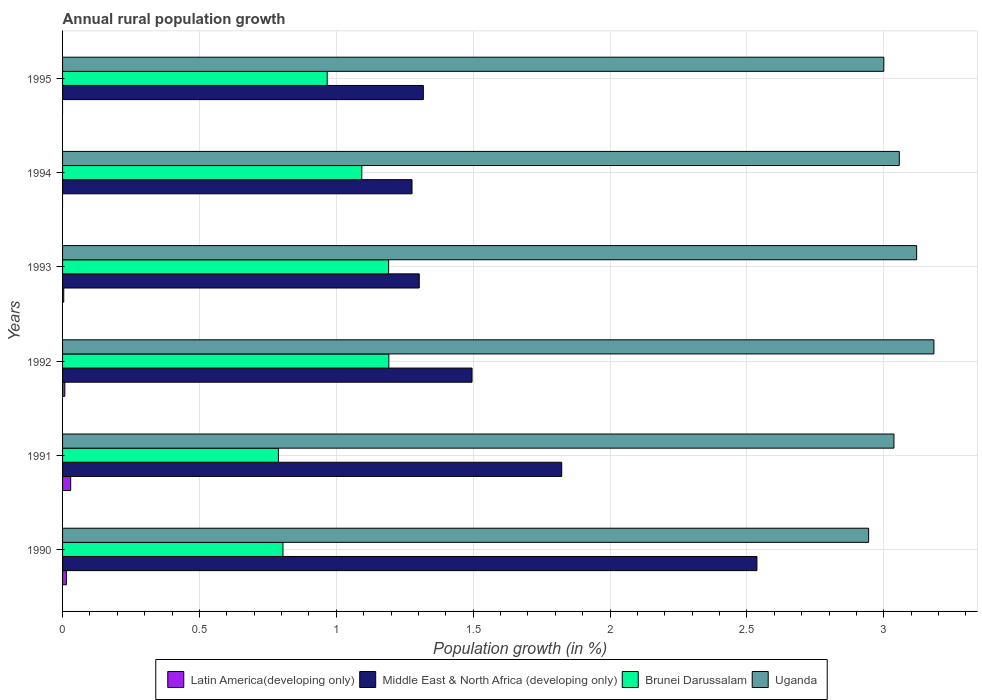How many different coloured bars are there?
Your answer should be compact. 4. Are the number of bars per tick equal to the number of legend labels?
Ensure brevity in your answer.  No. How many bars are there on the 5th tick from the top?
Offer a terse response. 4. What is the label of the 3rd group of bars from the top?
Provide a short and direct response. 1993. In how many cases, is the number of bars for a given year not equal to the number of legend labels?
Provide a short and direct response. 2. What is the percentage of rural population growth in Middle East & North Africa (developing only) in 1993?
Your answer should be compact. 1.3. Across all years, what is the maximum percentage of rural population growth in Latin America(developing only)?
Provide a succinct answer. 0.03. What is the total percentage of rural population growth in Brunei Darussalam in the graph?
Your answer should be very brief. 6.04. What is the difference between the percentage of rural population growth in Latin America(developing only) in 1991 and that in 1992?
Your response must be concise. 0.02. What is the difference between the percentage of rural population growth in Uganda in 1990 and the percentage of rural population growth in Middle East & North Africa (developing only) in 1991?
Keep it short and to the point. 1.12. What is the average percentage of rural population growth in Brunei Darussalam per year?
Make the answer very short. 1.01. In the year 1990, what is the difference between the percentage of rural population growth in Middle East & North Africa (developing only) and percentage of rural population growth in Uganda?
Provide a succinct answer. -0.41. What is the ratio of the percentage of rural population growth in Middle East & North Africa (developing only) in 1993 to that in 1995?
Ensure brevity in your answer.  0.99. Is the percentage of rural population growth in Middle East & North Africa (developing only) in 1992 less than that in 1993?
Give a very brief answer. No. What is the difference between the highest and the second highest percentage of rural population growth in Uganda?
Your response must be concise. 0.06. What is the difference between the highest and the lowest percentage of rural population growth in Uganda?
Provide a succinct answer. 0.24. Is the sum of the percentage of rural population growth in Middle East & North Africa (developing only) in 1994 and 1995 greater than the maximum percentage of rural population growth in Latin America(developing only) across all years?
Provide a succinct answer. Yes. Is it the case that in every year, the sum of the percentage of rural population growth in Uganda and percentage of rural population growth in Latin America(developing only) is greater than the percentage of rural population growth in Brunei Darussalam?
Your answer should be compact. Yes. How many bars are there?
Make the answer very short. 22. Are all the bars in the graph horizontal?
Your answer should be compact. Yes. Are the values on the major ticks of X-axis written in scientific E-notation?
Make the answer very short. No. Does the graph contain any zero values?
Your answer should be very brief. Yes. What is the title of the graph?
Ensure brevity in your answer.  Annual rural population growth. Does "Middle income" appear as one of the legend labels in the graph?
Offer a very short reply. No. What is the label or title of the X-axis?
Keep it short and to the point. Population growth (in %). What is the Population growth (in %) of Latin America(developing only) in 1990?
Give a very brief answer. 0.01. What is the Population growth (in %) of Middle East & North Africa (developing only) in 1990?
Your response must be concise. 2.54. What is the Population growth (in %) of Brunei Darussalam in 1990?
Offer a very short reply. 0.81. What is the Population growth (in %) of Uganda in 1990?
Your response must be concise. 2.94. What is the Population growth (in %) in Latin America(developing only) in 1991?
Offer a terse response. 0.03. What is the Population growth (in %) in Middle East & North Africa (developing only) in 1991?
Offer a terse response. 1.82. What is the Population growth (in %) of Brunei Darussalam in 1991?
Ensure brevity in your answer.  0.79. What is the Population growth (in %) of Uganda in 1991?
Provide a succinct answer. 3.04. What is the Population growth (in %) in Latin America(developing only) in 1992?
Your response must be concise. 0.01. What is the Population growth (in %) of Middle East & North Africa (developing only) in 1992?
Your answer should be very brief. 1.5. What is the Population growth (in %) of Brunei Darussalam in 1992?
Make the answer very short. 1.19. What is the Population growth (in %) of Uganda in 1992?
Keep it short and to the point. 3.18. What is the Population growth (in %) in Latin America(developing only) in 1993?
Your answer should be compact. 0. What is the Population growth (in %) of Middle East & North Africa (developing only) in 1993?
Offer a very short reply. 1.3. What is the Population growth (in %) of Brunei Darussalam in 1993?
Your answer should be very brief. 1.19. What is the Population growth (in %) of Uganda in 1993?
Provide a short and direct response. 3.12. What is the Population growth (in %) in Latin America(developing only) in 1994?
Offer a terse response. 0. What is the Population growth (in %) of Middle East & North Africa (developing only) in 1994?
Make the answer very short. 1.28. What is the Population growth (in %) in Brunei Darussalam in 1994?
Provide a succinct answer. 1.09. What is the Population growth (in %) in Uganda in 1994?
Your response must be concise. 3.06. What is the Population growth (in %) in Latin America(developing only) in 1995?
Provide a succinct answer. 0. What is the Population growth (in %) of Middle East & North Africa (developing only) in 1995?
Your answer should be very brief. 1.32. What is the Population growth (in %) in Brunei Darussalam in 1995?
Offer a terse response. 0.97. What is the Population growth (in %) in Uganda in 1995?
Provide a succinct answer. 3. Across all years, what is the maximum Population growth (in %) in Latin America(developing only)?
Make the answer very short. 0.03. Across all years, what is the maximum Population growth (in %) of Middle East & North Africa (developing only)?
Make the answer very short. 2.54. Across all years, what is the maximum Population growth (in %) of Brunei Darussalam?
Your answer should be very brief. 1.19. Across all years, what is the maximum Population growth (in %) in Uganda?
Offer a terse response. 3.18. Across all years, what is the minimum Population growth (in %) in Middle East & North Africa (developing only)?
Provide a short and direct response. 1.28. Across all years, what is the minimum Population growth (in %) of Brunei Darussalam?
Provide a short and direct response. 0.79. Across all years, what is the minimum Population growth (in %) of Uganda?
Make the answer very short. 2.94. What is the total Population growth (in %) in Latin America(developing only) in the graph?
Make the answer very short. 0.06. What is the total Population growth (in %) in Middle East & North Africa (developing only) in the graph?
Offer a very short reply. 9.75. What is the total Population growth (in %) of Brunei Darussalam in the graph?
Offer a very short reply. 6.04. What is the total Population growth (in %) of Uganda in the graph?
Offer a very short reply. 18.34. What is the difference between the Population growth (in %) of Latin America(developing only) in 1990 and that in 1991?
Your answer should be compact. -0.02. What is the difference between the Population growth (in %) in Middle East & North Africa (developing only) in 1990 and that in 1991?
Offer a very short reply. 0.71. What is the difference between the Population growth (in %) in Brunei Darussalam in 1990 and that in 1991?
Make the answer very short. 0.02. What is the difference between the Population growth (in %) in Uganda in 1990 and that in 1991?
Your answer should be compact. -0.09. What is the difference between the Population growth (in %) of Latin America(developing only) in 1990 and that in 1992?
Provide a succinct answer. 0.01. What is the difference between the Population growth (in %) in Middle East & North Africa (developing only) in 1990 and that in 1992?
Your response must be concise. 1.04. What is the difference between the Population growth (in %) of Brunei Darussalam in 1990 and that in 1992?
Make the answer very short. -0.39. What is the difference between the Population growth (in %) in Uganda in 1990 and that in 1992?
Offer a terse response. -0.24. What is the difference between the Population growth (in %) in Latin America(developing only) in 1990 and that in 1993?
Provide a short and direct response. 0.01. What is the difference between the Population growth (in %) of Middle East & North Africa (developing only) in 1990 and that in 1993?
Your answer should be very brief. 1.23. What is the difference between the Population growth (in %) of Brunei Darussalam in 1990 and that in 1993?
Your answer should be compact. -0.39. What is the difference between the Population growth (in %) in Uganda in 1990 and that in 1993?
Give a very brief answer. -0.18. What is the difference between the Population growth (in %) in Middle East & North Africa (developing only) in 1990 and that in 1994?
Your answer should be very brief. 1.26. What is the difference between the Population growth (in %) in Brunei Darussalam in 1990 and that in 1994?
Your answer should be very brief. -0.29. What is the difference between the Population growth (in %) of Uganda in 1990 and that in 1994?
Your answer should be compact. -0.11. What is the difference between the Population growth (in %) of Middle East & North Africa (developing only) in 1990 and that in 1995?
Ensure brevity in your answer.  1.22. What is the difference between the Population growth (in %) of Brunei Darussalam in 1990 and that in 1995?
Offer a terse response. -0.16. What is the difference between the Population growth (in %) of Uganda in 1990 and that in 1995?
Make the answer very short. -0.06. What is the difference between the Population growth (in %) of Latin America(developing only) in 1991 and that in 1992?
Your answer should be compact. 0.02. What is the difference between the Population growth (in %) of Middle East & North Africa (developing only) in 1991 and that in 1992?
Ensure brevity in your answer.  0.33. What is the difference between the Population growth (in %) of Brunei Darussalam in 1991 and that in 1992?
Provide a succinct answer. -0.4. What is the difference between the Population growth (in %) of Uganda in 1991 and that in 1992?
Give a very brief answer. -0.15. What is the difference between the Population growth (in %) of Latin America(developing only) in 1991 and that in 1993?
Provide a succinct answer. 0.03. What is the difference between the Population growth (in %) of Middle East & North Africa (developing only) in 1991 and that in 1993?
Offer a very short reply. 0.52. What is the difference between the Population growth (in %) of Brunei Darussalam in 1991 and that in 1993?
Your response must be concise. -0.4. What is the difference between the Population growth (in %) of Uganda in 1991 and that in 1993?
Keep it short and to the point. -0.08. What is the difference between the Population growth (in %) of Middle East & North Africa (developing only) in 1991 and that in 1994?
Offer a terse response. 0.55. What is the difference between the Population growth (in %) in Brunei Darussalam in 1991 and that in 1994?
Your answer should be very brief. -0.3. What is the difference between the Population growth (in %) in Uganda in 1991 and that in 1994?
Your answer should be very brief. -0.02. What is the difference between the Population growth (in %) in Middle East & North Africa (developing only) in 1991 and that in 1995?
Your answer should be compact. 0.51. What is the difference between the Population growth (in %) of Brunei Darussalam in 1991 and that in 1995?
Offer a very short reply. -0.18. What is the difference between the Population growth (in %) in Uganda in 1991 and that in 1995?
Offer a terse response. 0.04. What is the difference between the Population growth (in %) in Latin America(developing only) in 1992 and that in 1993?
Your answer should be very brief. 0. What is the difference between the Population growth (in %) of Middle East & North Africa (developing only) in 1992 and that in 1993?
Ensure brevity in your answer.  0.19. What is the difference between the Population growth (in %) of Brunei Darussalam in 1992 and that in 1993?
Your response must be concise. 0. What is the difference between the Population growth (in %) in Uganda in 1992 and that in 1993?
Provide a short and direct response. 0.06. What is the difference between the Population growth (in %) of Middle East & North Africa (developing only) in 1992 and that in 1994?
Ensure brevity in your answer.  0.22. What is the difference between the Population growth (in %) in Brunei Darussalam in 1992 and that in 1994?
Give a very brief answer. 0.1. What is the difference between the Population growth (in %) of Uganda in 1992 and that in 1994?
Make the answer very short. 0.13. What is the difference between the Population growth (in %) in Middle East & North Africa (developing only) in 1992 and that in 1995?
Ensure brevity in your answer.  0.18. What is the difference between the Population growth (in %) in Brunei Darussalam in 1992 and that in 1995?
Your answer should be compact. 0.23. What is the difference between the Population growth (in %) in Uganda in 1992 and that in 1995?
Provide a short and direct response. 0.18. What is the difference between the Population growth (in %) in Middle East & North Africa (developing only) in 1993 and that in 1994?
Ensure brevity in your answer.  0.03. What is the difference between the Population growth (in %) in Brunei Darussalam in 1993 and that in 1994?
Make the answer very short. 0.1. What is the difference between the Population growth (in %) of Uganda in 1993 and that in 1994?
Ensure brevity in your answer.  0.06. What is the difference between the Population growth (in %) in Middle East & North Africa (developing only) in 1993 and that in 1995?
Ensure brevity in your answer.  -0.01. What is the difference between the Population growth (in %) of Brunei Darussalam in 1993 and that in 1995?
Make the answer very short. 0.22. What is the difference between the Population growth (in %) of Uganda in 1993 and that in 1995?
Your response must be concise. 0.12. What is the difference between the Population growth (in %) in Middle East & North Africa (developing only) in 1994 and that in 1995?
Provide a short and direct response. -0.04. What is the difference between the Population growth (in %) of Brunei Darussalam in 1994 and that in 1995?
Offer a very short reply. 0.13. What is the difference between the Population growth (in %) in Uganda in 1994 and that in 1995?
Your response must be concise. 0.06. What is the difference between the Population growth (in %) of Latin America(developing only) in 1990 and the Population growth (in %) of Middle East & North Africa (developing only) in 1991?
Your answer should be very brief. -1.81. What is the difference between the Population growth (in %) in Latin America(developing only) in 1990 and the Population growth (in %) in Brunei Darussalam in 1991?
Offer a very short reply. -0.77. What is the difference between the Population growth (in %) of Latin America(developing only) in 1990 and the Population growth (in %) of Uganda in 1991?
Ensure brevity in your answer.  -3.02. What is the difference between the Population growth (in %) of Middle East & North Africa (developing only) in 1990 and the Population growth (in %) of Brunei Darussalam in 1991?
Your answer should be very brief. 1.75. What is the difference between the Population growth (in %) in Middle East & North Africa (developing only) in 1990 and the Population growth (in %) in Uganda in 1991?
Your answer should be compact. -0.5. What is the difference between the Population growth (in %) of Brunei Darussalam in 1990 and the Population growth (in %) of Uganda in 1991?
Provide a short and direct response. -2.23. What is the difference between the Population growth (in %) of Latin America(developing only) in 1990 and the Population growth (in %) of Middle East & North Africa (developing only) in 1992?
Give a very brief answer. -1.48. What is the difference between the Population growth (in %) of Latin America(developing only) in 1990 and the Population growth (in %) of Brunei Darussalam in 1992?
Your response must be concise. -1.18. What is the difference between the Population growth (in %) of Latin America(developing only) in 1990 and the Population growth (in %) of Uganda in 1992?
Your answer should be compact. -3.17. What is the difference between the Population growth (in %) in Middle East & North Africa (developing only) in 1990 and the Population growth (in %) in Brunei Darussalam in 1992?
Offer a terse response. 1.34. What is the difference between the Population growth (in %) in Middle East & North Africa (developing only) in 1990 and the Population growth (in %) in Uganda in 1992?
Make the answer very short. -0.65. What is the difference between the Population growth (in %) in Brunei Darussalam in 1990 and the Population growth (in %) in Uganda in 1992?
Offer a terse response. -2.38. What is the difference between the Population growth (in %) of Latin America(developing only) in 1990 and the Population growth (in %) of Middle East & North Africa (developing only) in 1993?
Give a very brief answer. -1.29. What is the difference between the Population growth (in %) of Latin America(developing only) in 1990 and the Population growth (in %) of Brunei Darussalam in 1993?
Provide a short and direct response. -1.18. What is the difference between the Population growth (in %) in Latin America(developing only) in 1990 and the Population growth (in %) in Uganda in 1993?
Keep it short and to the point. -3.11. What is the difference between the Population growth (in %) of Middle East & North Africa (developing only) in 1990 and the Population growth (in %) of Brunei Darussalam in 1993?
Keep it short and to the point. 1.35. What is the difference between the Population growth (in %) of Middle East & North Africa (developing only) in 1990 and the Population growth (in %) of Uganda in 1993?
Give a very brief answer. -0.58. What is the difference between the Population growth (in %) in Brunei Darussalam in 1990 and the Population growth (in %) in Uganda in 1993?
Keep it short and to the point. -2.31. What is the difference between the Population growth (in %) of Latin America(developing only) in 1990 and the Population growth (in %) of Middle East & North Africa (developing only) in 1994?
Provide a succinct answer. -1.26. What is the difference between the Population growth (in %) of Latin America(developing only) in 1990 and the Population growth (in %) of Brunei Darussalam in 1994?
Make the answer very short. -1.08. What is the difference between the Population growth (in %) in Latin America(developing only) in 1990 and the Population growth (in %) in Uganda in 1994?
Your answer should be very brief. -3.04. What is the difference between the Population growth (in %) of Middle East & North Africa (developing only) in 1990 and the Population growth (in %) of Brunei Darussalam in 1994?
Make the answer very short. 1.44. What is the difference between the Population growth (in %) in Middle East & North Africa (developing only) in 1990 and the Population growth (in %) in Uganda in 1994?
Provide a short and direct response. -0.52. What is the difference between the Population growth (in %) of Brunei Darussalam in 1990 and the Population growth (in %) of Uganda in 1994?
Provide a short and direct response. -2.25. What is the difference between the Population growth (in %) in Latin America(developing only) in 1990 and the Population growth (in %) in Middle East & North Africa (developing only) in 1995?
Your answer should be very brief. -1.3. What is the difference between the Population growth (in %) in Latin America(developing only) in 1990 and the Population growth (in %) in Brunei Darussalam in 1995?
Your response must be concise. -0.95. What is the difference between the Population growth (in %) of Latin America(developing only) in 1990 and the Population growth (in %) of Uganda in 1995?
Your answer should be very brief. -2.99. What is the difference between the Population growth (in %) of Middle East & North Africa (developing only) in 1990 and the Population growth (in %) of Brunei Darussalam in 1995?
Offer a terse response. 1.57. What is the difference between the Population growth (in %) of Middle East & North Africa (developing only) in 1990 and the Population growth (in %) of Uganda in 1995?
Your answer should be very brief. -0.46. What is the difference between the Population growth (in %) of Brunei Darussalam in 1990 and the Population growth (in %) of Uganda in 1995?
Offer a terse response. -2.19. What is the difference between the Population growth (in %) in Latin America(developing only) in 1991 and the Population growth (in %) in Middle East & North Africa (developing only) in 1992?
Your response must be concise. -1.47. What is the difference between the Population growth (in %) of Latin America(developing only) in 1991 and the Population growth (in %) of Brunei Darussalam in 1992?
Provide a succinct answer. -1.16. What is the difference between the Population growth (in %) in Latin America(developing only) in 1991 and the Population growth (in %) in Uganda in 1992?
Offer a very short reply. -3.15. What is the difference between the Population growth (in %) in Middle East & North Africa (developing only) in 1991 and the Population growth (in %) in Brunei Darussalam in 1992?
Offer a very short reply. 0.63. What is the difference between the Population growth (in %) of Middle East & North Africa (developing only) in 1991 and the Population growth (in %) of Uganda in 1992?
Your response must be concise. -1.36. What is the difference between the Population growth (in %) of Brunei Darussalam in 1991 and the Population growth (in %) of Uganda in 1992?
Provide a succinct answer. -2.39. What is the difference between the Population growth (in %) in Latin America(developing only) in 1991 and the Population growth (in %) in Middle East & North Africa (developing only) in 1993?
Give a very brief answer. -1.27. What is the difference between the Population growth (in %) of Latin America(developing only) in 1991 and the Population growth (in %) of Brunei Darussalam in 1993?
Your answer should be compact. -1.16. What is the difference between the Population growth (in %) of Latin America(developing only) in 1991 and the Population growth (in %) of Uganda in 1993?
Your response must be concise. -3.09. What is the difference between the Population growth (in %) in Middle East & North Africa (developing only) in 1991 and the Population growth (in %) in Brunei Darussalam in 1993?
Provide a succinct answer. 0.63. What is the difference between the Population growth (in %) in Middle East & North Africa (developing only) in 1991 and the Population growth (in %) in Uganda in 1993?
Keep it short and to the point. -1.3. What is the difference between the Population growth (in %) of Brunei Darussalam in 1991 and the Population growth (in %) of Uganda in 1993?
Your answer should be compact. -2.33. What is the difference between the Population growth (in %) of Latin America(developing only) in 1991 and the Population growth (in %) of Middle East & North Africa (developing only) in 1994?
Your answer should be compact. -1.25. What is the difference between the Population growth (in %) in Latin America(developing only) in 1991 and the Population growth (in %) in Brunei Darussalam in 1994?
Keep it short and to the point. -1.06. What is the difference between the Population growth (in %) of Latin America(developing only) in 1991 and the Population growth (in %) of Uganda in 1994?
Offer a terse response. -3.03. What is the difference between the Population growth (in %) of Middle East & North Africa (developing only) in 1991 and the Population growth (in %) of Brunei Darussalam in 1994?
Provide a succinct answer. 0.73. What is the difference between the Population growth (in %) of Middle East & North Africa (developing only) in 1991 and the Population growth (in %) of Uganda in 1994?
Your answer should be compact. -1.23. What is the difference between the Population growth (in %) in Brunei Darussalam in 1991 and the Population growth (in %) in Uganda in 1994?
Ensure brevity in your answer.  -2.27. What is the difference between the Population growth (in %) in Latin America(developing only) in 1991 and the Population growth (in %) in Middle East & North Africa (developing only) in 1995?
Keep it short and to the point. -1.29. What is the difference between the Population growth (in %) of Latin America(developing only) in 1991 and the Population growth (in %) of Brunei Darussalam in 1995?
Provide a short and direct response. -0.94. What is the difference between the Population growth (in %) in Latin America(developing only) in 1991 and the Population growth (in %) in Uganda in 1995?
Offer a very short reply. -2.97. What is the difference between the Population growth (in %) of Middle East & North Africa (developing only) in 1991 and the Population growth (in %) of Brunei Darussalam in 1995?
Offer a very short reply. 0.86. What is the difference between the Population growth (in %) of Middle East & North Africa (developing only) in 1991 and the Population growth (in %) of Uganda in 1995?
Offer a very short reply. -1.18. What is the difference between the Population growth (in %) in Brunei Darussalam in 1991 and the Population growth (in %) in Uganda in 1995?
Provide a short and direct response. -2.21. What is the difference between the Population growth (in %) of Latin America(developing only) in 1992 and the Population growth (in %) of Middle East & North Africa (developing only) in 1993?
Provide a short and direct response. -1.29. What is the difference between the Population growth (in %) in Latin America(developing only) in 1992 and the Population growth (in %) in Brunei Darussalam in 1993?
Make the answer very short. -1.18. What is the difference between the Population growth (in %) of Latin America(developing only) in 1992 and the Population growth (in %) of Uganda in 1993?
Give a very brief answer. -3.11. What is the difference between the Population growth (in %) of Middle East & North Africa (developing only) in 1992 and the Population growth (in %) of Brunei Darussalam in 1993?
Provide a short and direct response. 0.3. What is the difference between the Population growth (in %) of Middle East & North Africa (developing only) in 1992 and the Population growth (in %) of Uganda in 1993?
Your answer should be compact. -1.62. What is the difference between the Population growth (in %) of Brunei Darussalam in 1992 and the Population growth (in %) of Uganda in 1993?
Give a very brief answer. -1.93. What is the difference between the Population growth (in %) of Latin America(developing only) in 1992 and the Population growth (in %) of Middle East & North Africa (developing only) in 1994?
Provide a succinct answer. -1.27. What is the difference between the Population growth (in %) of Latin America(developing only) in 1992 and the Population growth (in %) of Brunei Darussalam in 1994?
Provide a short and direct response. -1.08. What is the difference between the Population growth (in %) in Latin America(developing only) in 1992 and the Population growth (in %) in Uganda in 1994?
Give a very brief answer. -3.05. What is the difference between the Population growth (in %) in Middle East & North Africa (developing only) in 1992 and the Population growth (in %) in Brunei Darussalam in 1994?
Offer a terse response. 0.4. What is the difference between the Population growth (in %) in Middle East & North Africa (developing only) in 1992 and the Population growth (in %) in Uganda in 1994?
Keep it short and to the point. -1.56. What is the difference between the Population growth (in %) of Brunei Darussalam in 1992 and the Population growth (in %) of Uganda in 1994?
Give a very brief answer. -1.86. What is the difference between the Population growth (in %) in Latin America(developing only) in 1992 and the Population growth (in %) in Middle East & North Africa (developing only) in 1995?
Offer a very short reply. -1.31. What is the difference between the Population growth (in %) of Latin America(developing only) in 1992 and the Population growth (in %) of Brunei Darussalam in 1995?
Provide a short and direct response. -0.96. What is the difference between the Population growth (in %) in Latin America(developing only) in 1992 and the Population growth (in %) in Uganda in 1995?
Your answer should be very brief. -2.99. What is the difference between the Population growth (in %) of Middle East & North Africa (developing only) in 1992 and the Population growth (in %) of Brunei Darussalam in 1995?
Provide a succinct answer. 0.53. What is the difference between the Population growth (in %) of Middle East & North Africa (developing only) in 1992 and the Population growth (in %) of Uganda in 1995?
Offer a very short reply. -1.5. What is the difference between the Population growth (in %) in Brunei Darussalam in 1992 and the Population growth (in %) in Uganda in 1995?
Your answer should be compact. -1.81. What is the difference between the Population growth (in %) in Latin America(developing only) in 1993 and the Population growth (in %) in Middle East & North Africa (developing only) in 1994?
Offer a terse response. -1.27. What is the difference between the Population growth (in %) of Latin America(developing only) in 1993 and the Population growth (in %) of Brunei Darussalam in 1994?
Offer a very short reply. -1.09. What is the difference between the Population growth (in %) in Latin America(developing only) in 1993 and the Population growth (in %) in Uganda in 1994?
Offer a very short reply. -3.05. What is the difference between the Population growth (in %) of Middle East & North Africa (developing only) in 1993 and the Population growth (in %) of Brunei Darussalam in 1994?
Give a very brief answer. 0.21. What is the difference between the Population growth (in %) of Middle East & North Africa (developing only) in 1993 and the Population growth (in %) of Uganda in 1994?
Provide a succinct answer. -1.75. What is the difference between the Population growth (in %) in Brunei Darussalam in 1993 and the Population growth (in %) in Uganda in 1994?
Offer a terse response. -1.87. What is the difference between the Population growth (in %) in Latin America(developing only) in 1993 and the Population growth (in %) in Middle East & North Africa (developing only) in 1995?
Offer a terse response. -1.31. What is the difference between the Population growth (in %) of Latin America(developing only) in 1993 and the Population growth (in %) of Brunei Darussalam in 1995?
Your answer should be very brief. -0.96. What is the difference between the Population growth (in %) of Latin America(developing only) in 1993 and the Population growth (in %) of Uganda in 1995?
Keep it short and to the point. -3. What is the difference between the Population growth (in %) in Middle East & North Africa (developing only) in 1993 and the Population growth (in %) in Brunei Darussalam in 1995?
Offer a terse response. 0.34. What is the difference between the Population growth (in %) in Middle East & North Africa (developing only) in 1993 and the Population growth (in %) in Uganda in 1995?
Give a very brief answer. -1.7. What is the difference between the Population growth (in %) of Brunei Darussalam in 1993 and the Population growth (in %) of Uganda in 1995?
Your response must be concise. -1.81. What is the difference between the Population growth (in %) of Middle East & North Africa (developing only) in 1994 and the Population growth (in %) of Brunei Darussalam in 1995?
Keep it short and to the point. 0.31. What is the difference between the Population growth (in %) of Middle East & North Africa (developing only) in 1994 and the Population growth (in %) of Uganda in 1995?
Keep it short and to the point. -1.72. What is the difference between the Population growth (in %) in Brunei Darussalam in 1994 and the Population growth (in %) in Uganda in 1995?
Make the answer very short. -1.91. What is the average Population growth (in %) of Latin America(developing only) per year?
Offer a terse response. 0.01. What is the average Population growth (in %) in Middle East & North Africa (developing only) per year?
Make the answer very short. 1.63. What is the average Population growth (in %) of Brunei Darussalam per year?
Your response must be concise. 1.01. What is the average Population growth (in %) in Uganda per year?
Offer a terse response. 3.06. In the year 1990, what is the difference between the Population growth (in %) in Latin America(developing only) and Population growth (in %) in Middle East & North Africa (developing only)?
Keep it short and to the point. -2.52. In the year 1990, what is the difference between the Population growth (in %) in Latin America(developing only) and Population growth (in %) in Brunei Darussalam?
Your response must be concise. -0.79. In the year 1990, what is the difference between the Population growth (in %) of Latin America(developing only) and Population growth (in %) of Uganda?
Your response must be concise. -2.93. In the year 1990, what is the difference between the Population growth (in %) in Middle East & North Africa (developing only) and Population growth (in %) in Brunei Darussalam?
Provide a succinct answer. 1.73. In the year 1990, what is the difference between the Population growth (in %) of Middle East & North Africa (developing only) and Population growth (in %) of Uganda?
Your response must be concise. -0.41. In the year 1990, what is the difference between the Population growth (in %) of Brunei Darussalam and Population growth (in %) of Uganda?
Offer a very short reply. -2.14. In the year 1991, what is the difference between the Population growth (in %) in Latin America(developing only) and Population growth (in %) in Middle East & North Africa (developing only)?
Make the answer very short. -1.79. In the year 1991, what is the difference between the Population growth (in %) of Latin America(developing only) and Population growth (in %) of Brunei Darussalam?
Make the answer very short. -0.76. In the year 1991, what is the difference between the Population growth (in %) in Latin America(developing only) and Population growth (in %) in Uganda?
Provide a short and direct response. -3.01. In the year 1991, what is the difference between the Population growth (in %) of Middle East & North Africa (developing only) and Population growth (in %) of Brunei Darussalam?
Provide a short and direct response. 1.03. In the year 1991, what is the difference between the Population growth (in %) of Middle East & North Africa (developing only) and Population growth (in %) of Uganda?
Your answer should be compact. -1.21. In the year 1991, what is the difference between the Population growth (in %) of Brunei Darussalam and Population growth (in %) of Uganda?
Your response must be concise. -2.25. In the year 1992, what is the difference between the Population growth (in %) in Latin America(developing only) and Population growth (in %) in Middle East & North Africa (developing only)?
Ensure brevity in your answer.  -1.49. In the year 1992, what is the difference between the Population growth (in %) in Latin America(developing only) and Population growth (in %) in Brunei Darussalam?
Ensure brevity in your answer.  -1.18. In the year 1992, what is the difference between the Population growth (in %) of Latin America(developing only) and Population growth (in %) of Uganda?
Keep it short and to the point. -3.17. In the year 1992, what is the difference between the Population growth (in %) in Middle East & North Africa (developing only) and Population growth (in %) in Brunei Darussalam?
Ensure brevity in your answer.  0.3. In the year 1992, what is the difference between the Population growth (in %) in Middle East & North Africa (developing only) and Population growth (in %) in Uganda?
Provide a succinct answer. -1.69. In the year 1992, what is the difference between the Population growth (in %) in Brunei Darussalam and Population growth (in %) in Uganda?
Your response must be concise. -1.99. In the year 1993, what is the difference between the Population growth (in %) of Latin America(developing only) and Population growth (in %) of Middle East & North Africa (developing only)?
Keep it short and to the point. -1.3. In the year 1993, what is the difference between the Population growth (in %) of Latin America(developing only) and Population growth (in %) of Brunei Darussalam?
Keep it short and to the point. -1.19. In the year 1993, what is the difference between the Population growth (in %) of Latin America(developing only) and Population growth (in %) of Uganda?
Offer a terse response. -3.12. In the year 1993, what is the difference between the Population growth (in %) in Middle East & North Africa (developing only) and Population growth (in %) in Brunei Darussalam?
Provide a short and direct response. 0.11. In the year 1993, what is the difference between the Population growth (in %) in Middle East & North Africa (developing only) and Population growth (in %) in Uganda?
Offer a terse response. -1.82. In the year 1993, what is the difference between the Population growth (in %) of Brunei Darussalam and Population growth (in %) of Uganda?
Offer a terse response. -1.93. In the year 1994, what is the difference between the Population growth (in %) of Middle East & North Africa (developing only) and Population growth (in %) of Brunei Darussalam?
Offer a very short reply. 0.18. In the year 1994, what is the difference between the Population growth (in %) in Middle East & North Africa (developing only) and Population growth (in %) in Uganda?
Your answer should be compact. -1.78. In the year 1994, what is the difference between the Population growth (in %) in Brunei Darussalam and Population growth (in %) in Uganda?
Make the answer very short. -1.96. In the year 1995, what is the difference between the Population growth (in %) in Middle East & North Africa (developing only) and Population growth (in %) in Brunei Darussalam?
Your answer should be compact. 0.35. In the year 1995, what is the difference between the Population growth (in %) of Middle East & North Africa (developing only) and Population growth (in %) of Uganda?
Your answer should be compact. -1.68. In the year 1995, what is the difference between the Population growth (in %) of Brunei Darussalam and Population growth (in %) of Uganda?
Your answer should be compact. -2.03. What is the ratio of the Population growth (in %) in Latin America(developing only) in 1990 to that in 1991?
Your response must be concise. 0.47. What is the ratio of the Population growth (in %) of Middle East & North Africa (developing only) in 1990 to that in 1991?
Provide a short and direct response. 1.39. What is the ratio of the Population growth (in %) of Brunei Darussalam in 1990 to that in 1991?
Provide a short and direct response. 1.02. What is the ratio of the Population growth (in %) of Uganda in 1990 to that in 1991?
Offer a very short reply. 0.97. What is the ratio of the Population growth (in %) in Latin America(developing only) in 1990 to that in 1992?
Provide a short and direct response. 1.71. What is the ratio of the Population growth (in %) in Middle East & North Africa (developing only) in 1990 to that in 1992?
Make the answer very short. 1.7. What is the ratio of the Population growth (in %) of Brunei Darussalam in 1990 to that in 1992?
Offer a very short reply. 0.68. What is the ratio of the Population growth (in %) in Uganda in 1990 to that in 1992?
Provide a short and direct response. 0.93. What is the ratio of the Population growth (in %) in Latin America(developing only) in 1990 to that in 1993?
Your answer should be very brief. 3.25. What is the ratio of the Population growth (in %) of Middle East & North Africa (developing only) in 1990 to that in 1993?
Provide a succinct answer. 1.95. What is the ratio of the Population growth (in %) of Brunei Darussalam in 1990 to that in 1993?
Make the answer very short. 0.68. What is the ratio of the Population growth (in %) of Uganda in 1990 to that in 1993?
Offer a very short reply. 0.94. What is the ratio of the Population growth (in %) of Middle East & North Africa (developing only) in 1990 to that in 1994?
Offer a terse response. 1.99. What is the ratio of the Population growth (in %) of Brunei Darussalam in 1990 to that in 1994?
Keep it short and to the point. 0.74. What is the ratio of the Population growth (in %) of Uganda in 1990 to that in 1994?
Give a very brief answer. 0.96. What is the ratio of the Population growth (in %) in Middle East & North Africa (developing only) in 1990 to that in 1995?
Give a very brief answer. 1.92. What is the ratio of the Population growth (in %) in Brunei Darussalam in 1990 to that in 1995?
Keep it short and to the point. 0.83. What is the ratio of the Population growth (in %) of Uganda in 1990 to that in 1995?
Ensure brevity in your answer.  0.98. What is the ratio of the Population growth (in %) of Latin America(developing only) in 1991 to that in 1992?
Provide a succinct answer. 3.62. What is the ratio of the Population growth (in %) of Middle East & North Africa (developing only) in 1991 to that in 1992?
Ensure brevity in your answer.  1.22. What is the ratio of the Population growth (in %) of Brunei Darussalam in 1991 to that in 1992?
Your response must be concise. 0.66. What is the ratio of the Population growth (in %) in Uganda in 1991 to that in 1992?
Keep it short and to the point. 0.95. What is the ratio of the Population growth (in %) of Latin America(developing only) in 1991 to that in 1993?
Offer a very short reply. 6.88. What is the ratio of the Population growth (in %) in Middle East & North Africa (developing only) in 1991 to that in 1993?
Provide a succinct answer. 1.4. What is the ratio of the Population growth (in %) in Brunei Darussalam in 1991 to that in 1993?
Your answer should be compact. 0.66. What is the ratio of the Population growth (in %) of Uganda in 1991 to that in 1993?
Offer a very short reply. 0.97. What is the ratio of the Population growth (in %) of Middle East & North Africa (developing only) in 1991 to that in 1994?
Provide a succinct answer. 1.43. What is the ratio of the Population growth (in %) of Brunei Darussalam in 1991 to that in 1994?
Provide a short and direct response. 0.72. What is the ratio of the Population growth (in %) in Uganda in 1991 to that in 1994?
Offer a very short reply. 0.99. What is the ratio of the Population growth (in %) in Middle East & North Africa (developing only) in 1991 to that in 1995?
Your response must be concise. 1.38. What is the ratio of the Population growth (in %) in Brunei Darussalam in 1991 to that in 1995?
Your response must be concise. 0.82. What is the ratio of the Population growth (in %) of Uganda in 1991 to that in 1995?
Keep it short and to the point. 1.01. What is the ratio of the Population growth (in %) in Latin America(developing only) in 1992 to that in 1993?
Your answer should be very brief. 1.9. What is the ratio of the Population growth (in %) in Middle East & North Africa (developing only) in 1992 to that in 1993?
Provide a short and direct response. 1.15. What is the ratio of the Population growth (in %) of Brunei Darussalam in 1992 to that in 1993?
Give a very brief answer. 1. What is the ratio of the Population growth (in %) in Uganda in 1992 to that in 1993?
Your response must be concise. 1.02. What is the ratio of the Population growth (in %) in Middle East & North Africa (developing only) in 1992 to that in 1994?
Make the answer very short. 1.17. What is the ratio of the Population growth (in %) in Brunei Darussalam in 1992 to that in 1994?
Provide a succinct answer. 1.09. What is the ratio of the Population growth (in %) in Uganda in 1992 to that in 1994?
Your answer should be very brief. 1.04. What is the ratio of the Population growth (in %) of Middle East & North Africa (developing only) in 1992 to that in 1995?
Your response must be concise. 1.13. What is the ratio of the Population growth (in %) of Brunei Darussalam in 1992 to that in 1995?
Provide a short and direct response. 1.23. What is the ratio of the Population growth (in %) of Uganda in 1992 to that in 1995?
Keep it short and to the point. 1.06. What is the ratio of the Population growth (in %) of Middle East & North Africa (developing only) in 1993 to that in 1994?
Keep it short and to the point. 1.02. What is the ratio of the Population growth (in %) in Brunei Darussalam in 1993 to that in 1994?
Offer a very short reply. 1.09. What is the ratio of the Population growth (in %) in Uganda in 1993 to that in 1994?
Offer a very short reply. 1.02. What is the ratio of the Population growth (in %) in Brunei Darussalam in 1993 to that in 1995?
Make the answer very short. 1.23. What is the ratio of the Population growth (in %) in Middle East & North Africa (developing only) in 1994 to that in 1995?
Your answer should be compact. 0.97. What is the ratio of the Population growth (in %) in Brunei Darussalam in 1994 to that in 1995?
Your answer should be compact. 1.13. What is the ratio of the Population growth (in %) of Uganda in 1994 to that in 1995?
Provide a short and direct response. 1.02. What is the difference between the highest and the second highest Population growth (in %) of Latin America(developing only)?
Give a very brief answer. 0.02. What is the difference between the highest and the second highest Population growth (in %) of Middle East & North Africa (developing only)?
Provide a succinct answer. 0.71. What is the difference between the highest and the second highest Population growth (in %) in Brunei Darussalam?
Provide a short and direct response. 0. What is the difference between the highest and the second highest Population growth (in %) of Uganda?
Keep it short and to the point. 0.06. What is the difference between the highest and the lowest Population growth (in %) in Latin America(developing only)?
Your answer should be compact. 0.03. What is the difference between the highest and the lowest Population growth (in %) in Middle East & North Africa (developing only)?
Offer a very short reply. 1.26. What is the difference between the highest and the lowest Population growth (in %) of Brunei Darussalam?
Offer a terse response. 0.4. What is the difference between the highest and the lowest Population growth (in %) of Uganda?
Give a very brief answer. 0.24. 